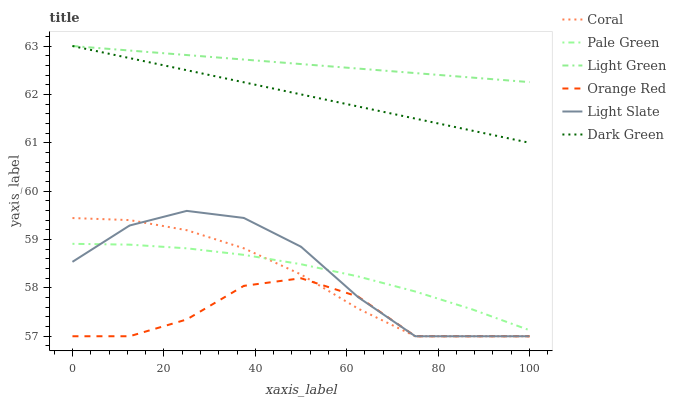Does Orange Red have the minimum area under the curve?
Answer yes or no. Yes. Does Light Green have the maximum area under the curve?
Answer yes or no. Yes. Does Coral have the minimum area under the curve?
Answer yes or no. No. Does Coral have the maximum area under the curve?
Answer yes or no. No. Is Dark Green the smoothest?
Answer yes or no. Yes. Is Orange Red the roughest?
Answer yes or no. Yes. Is Coral the smoothest?
Answer yes or no. No. Is Coral the roughest?
Answer yes or no. No. Does Light Slate have the lowest value?
Answer yes or no. Yes. Does Pale Green have the lowest value?
Answer yes or no. No. Does Dark Green have the highest value?
Answer yes or no. Yes. Does Coral have the highest value?
Answer yes or no. No. Is Light Slate less than Light Green?
Answer yes or no. Yes. Is Dark Green greater than Coral?
Answer yes or no. Yes. Does Orange Red intersect Light Slate?
Answer yes or no. Yes. Is Orange Red less than Light Slate?
Answer yes or no. No. Is Orange Red greater than Light Slate?
Answer yes or no. No. Does Light Slate intersect Light Green?
Answer yes or no. No. 